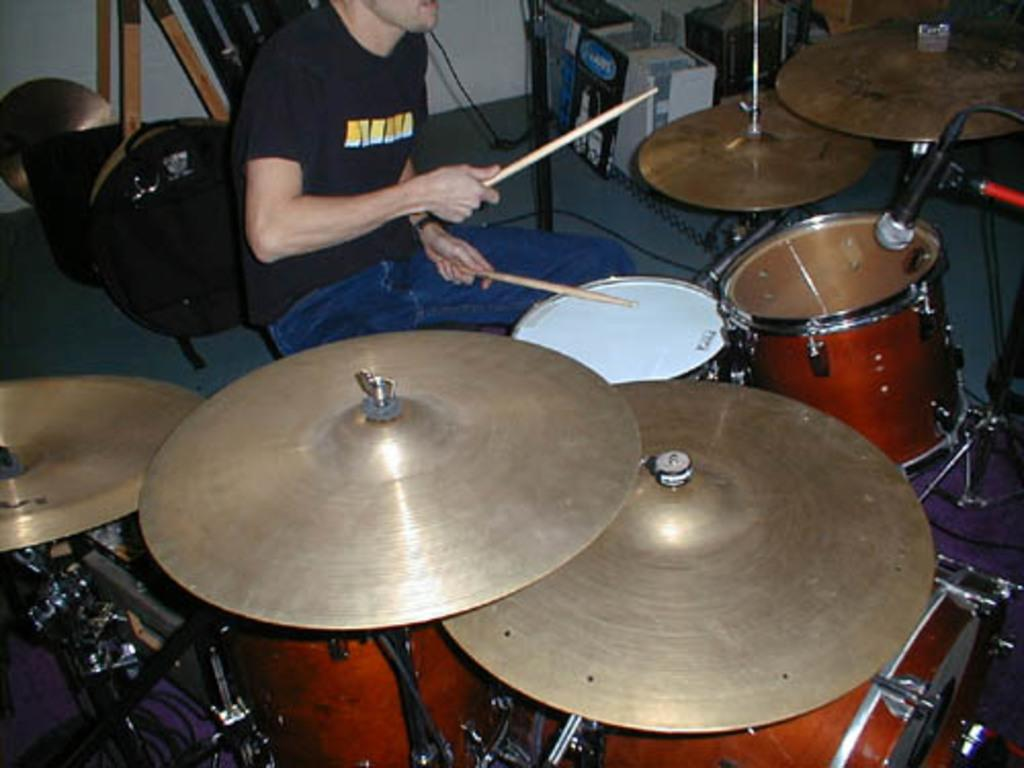What is the man in the image doing? The man is playing musical instruments in the image. How is the man playing the instruments? The man is using sticks to play the instruments. What type of musical instrument can be seen in the image? There is a musical drum in the image. What device is present in front of the musical drum? A microphone (mic) is present in front of the musical drum. How many apples are on the man's brain in the image? There are no apples or references to a brain in the image; the man is playing musical instruments. 